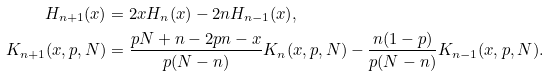Convert formula to latex. <formula><loc_0><loc_0><loc_500><loc_500>H _ { n + 1 } ( x ) & = 2 x H _ { n } ( x ) - 2 n H _ { n - 1 } ( x ) , \\ K _ { n + 1 } ( x , p , N ) & = \frac { p N + n - 2 p n - x } { p ( N - n ) } K _ { n } ( x , p , N ) - \frac { n ( 1 - p ) } { p ( N - n ) } K _ { n - 1 } ( x , p , N ) .</formula> 